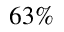Convert formula to latex. <formula><loc_0><loc_0><loc_500><loc_500>6 3 \%</formula> 